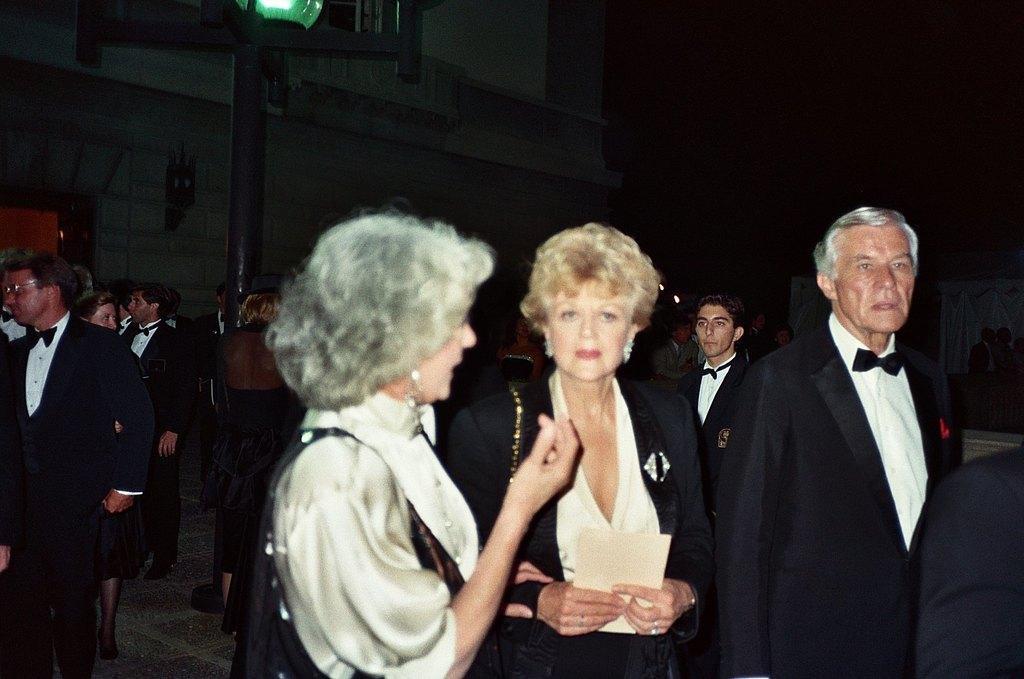Describe this image in one or two sentences. In this picture we can see some group of people are standing in one place, behind we can see the building. 